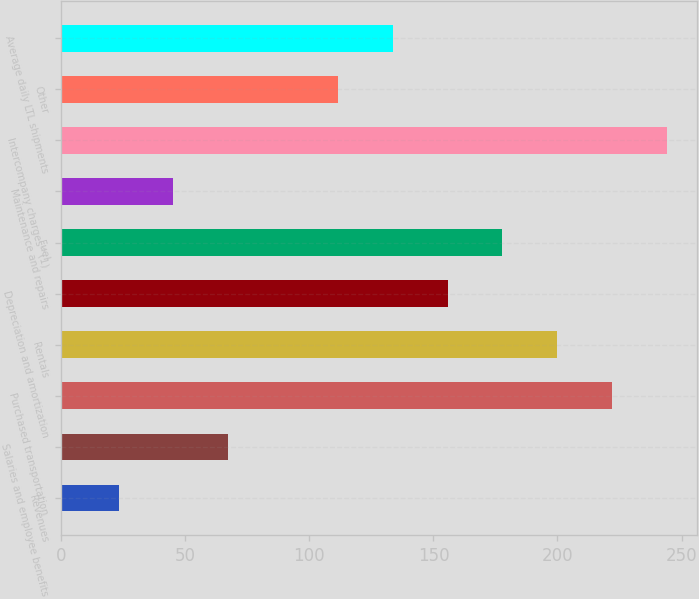Convert chart. <chart><loc_0><loc_0><loc_500><loc_500><bar_chart><fcel>Revenues<fcel>Salaries and employee benefits<fcel>Purchased transportation<fcel>Rentals<fcel>Depreciation and amortization<fcel>Fuel<fcel>Maintenance and repairs<fcel>Intercompany charges^(1)<fcel>Other<fcel>Average daily LTL shipments<nl><fcel>23.1<fcel>67.3<fcel>222<fcel>199.9<fcel>155.7<fcel>177.8<fcel>45.2<fcel>244.1<fcel>111.5<fcel>133.6<nl></chart> 